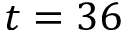Convert formula to latex. <formula><loc_0><loc_0><loc_500><loc_500>t = 3 6</formula> 